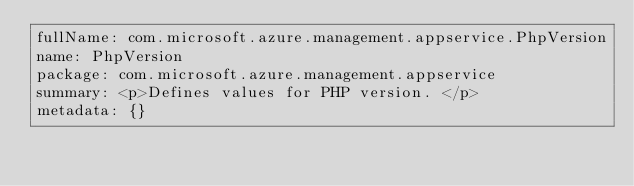<code> <loc_0><loc_0><loc_500><loc_500><_YAML_>fullName: com.microsoft.azure.management.appservice.PhpVersion
name: PhpVersion
package: com.microsoft.azure.management.appservice
summary: <p>Defines values for PHP version. </p>
metadata: {}
</code> 